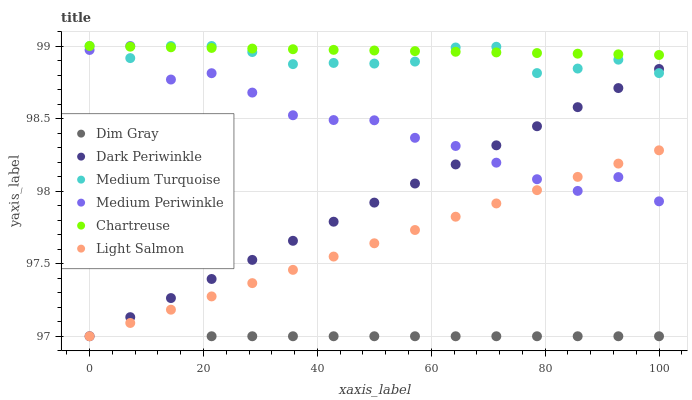Does Dim Gray have the minimum area under the curve?
Answer yes or no. Yes. Does Chartreuse have the maximum area under the curve?
Answer yes or no. Yes. Does Medium Periwinkle have the minimum area under the curve?
Answer yes or no. No. Does Medium Periwinkle have the maximum area under the curve?
Answer yes or no. No. Is Light Salmon the smoothest?
Answer yes or no. Yes. Is Medium Periwinkle the roughest?
Answer yes or no. Yes. Is Dim Gray the smoothest?
Answer yes or no. No. Is Dim Gray the roughest?
Answer yes or no. No. Does Light Salmon have the lowest value?
Answer yes or no. Yes. Does Medium Periwinkle have the lowest value?
Answer yes or no. No. Does Medium Turquoise have the highest value?
Answer yes or no. Yes. Does Dim Gray have the highest value?
Answer yes or no. No. Is Dim Gray less than Chartreuse?
Answer yes or no. Yes. Is Medium Turquoise greater than Dim Gray?
Answer yes or no. Yes. Does Medium Periwinkle intersect Light Salmon?
Answer yes or no. Yes. Is Medium Periwinkle less than Light Salmon?
Answer yes or no. No. Is Medium Periwinkle greater than Light Salmon?
Answer yes or no. No. Does Dim Gray intersect Chartreuse?
Answer yes or no. No. 